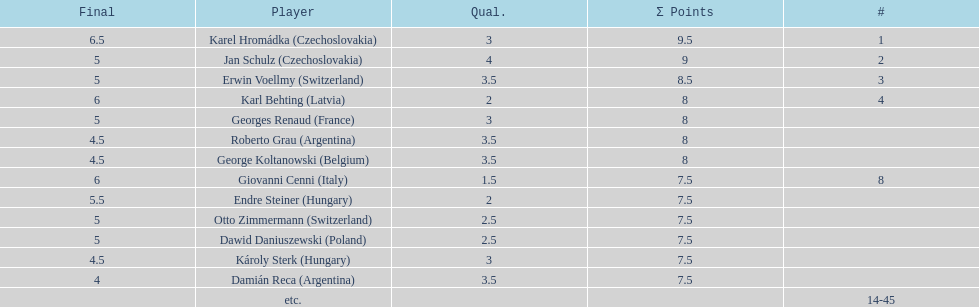Karl behting and giovanni cenni each had final scores of what? 6. 